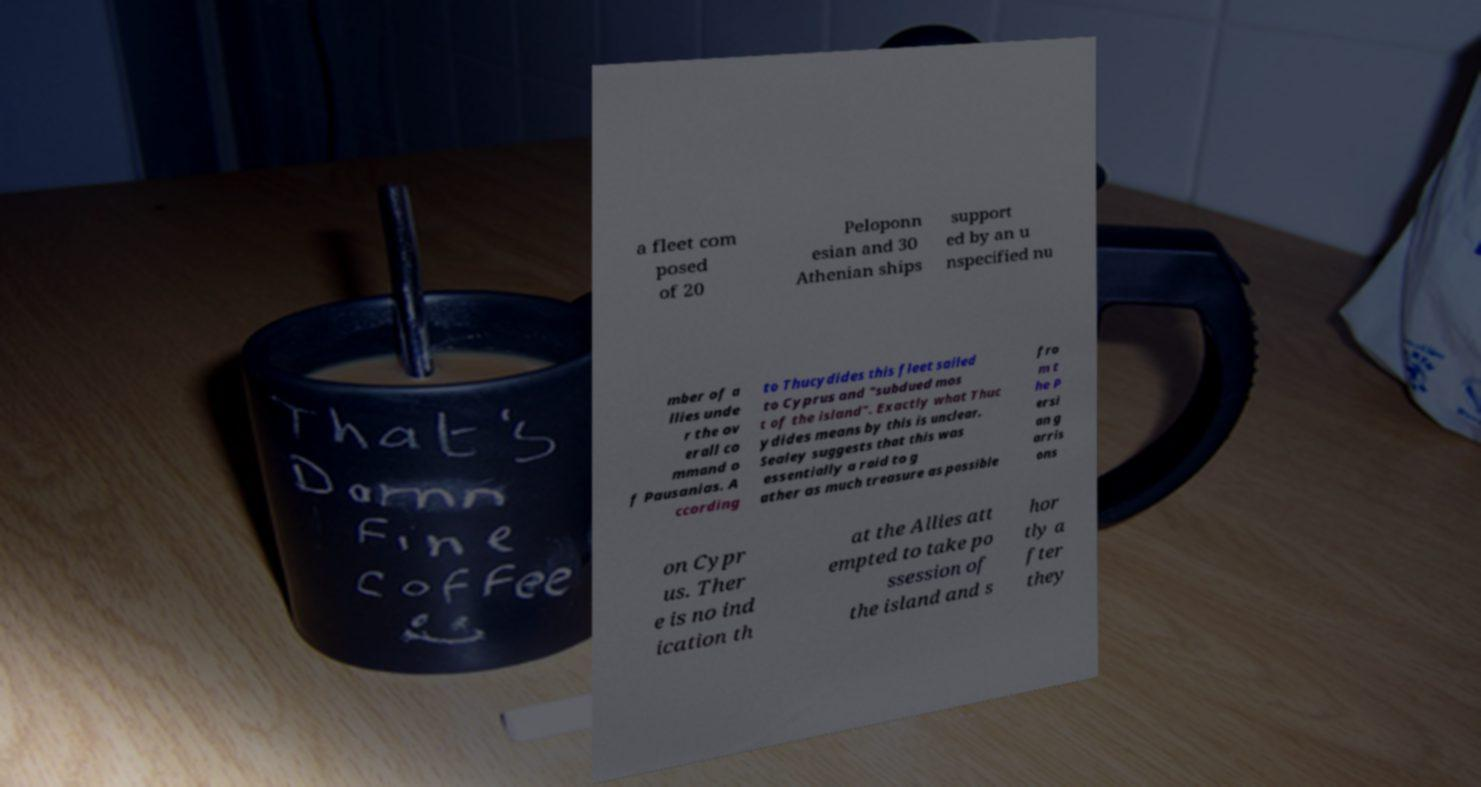I need the written content from this picture converted into text. Can you do that? a fleet com posed of 20 Peloponn esian and 30 Athenian ships support ed by an u nspecified nu mber of a llies unde r the ov erall co mmand o f Pausanias. A ccording to Thucydides this fleet sailed to Cyprus and "subdued mos t of the island". Exactly what Thuc ydides means by this is unclear. Sealey suggests that this was essentially a raid to g ather as much treasure as possible fro m t he P ersi an g arris ons on Cypr us. Ther e is no ind ication th at the Allies att empted to take po ssession of the island and s hor tly a fter they 